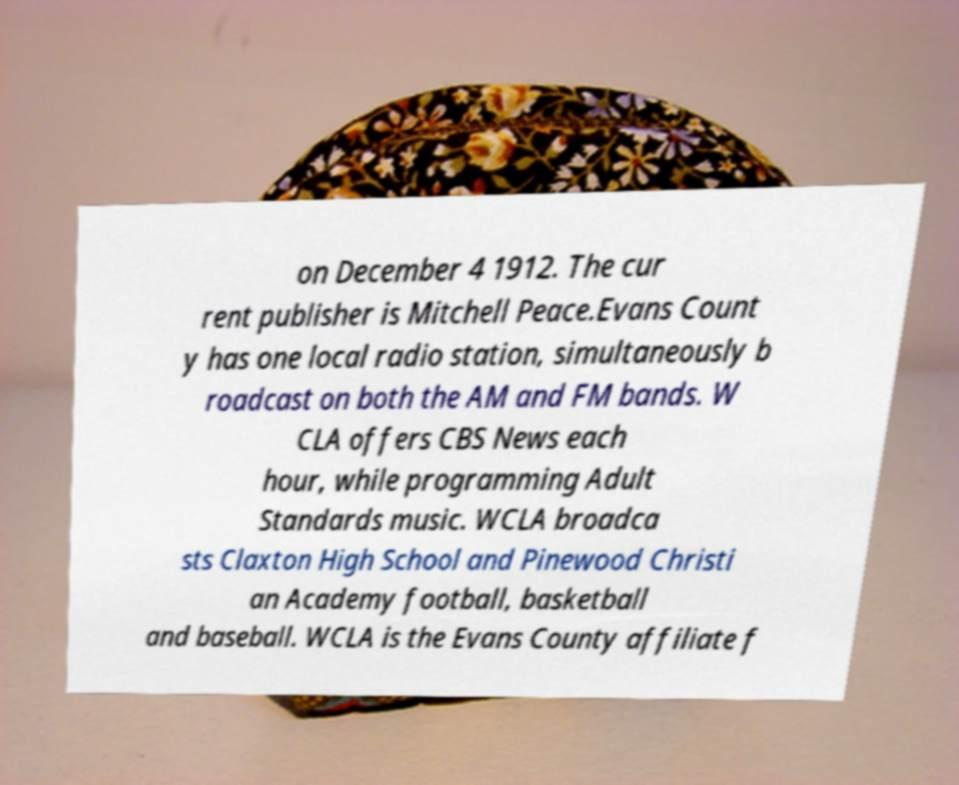Can you read and provide the text displayed in the image?This photo seems to have some interesting text. Can you extract and type it out for me? on December 4 1912. The cur rent publisher is Mitchell Peace.Evans Count y has one local radio station, simultaneously b roadcast on both the AM and FM bands. W CLA offers CBS News each hour, while programming Adult Standards music. WCLA broadca sts Claxton High School and Pinewood Christi an Academy football, basketball and baseball. WCLA is the Evans County affiliate f 